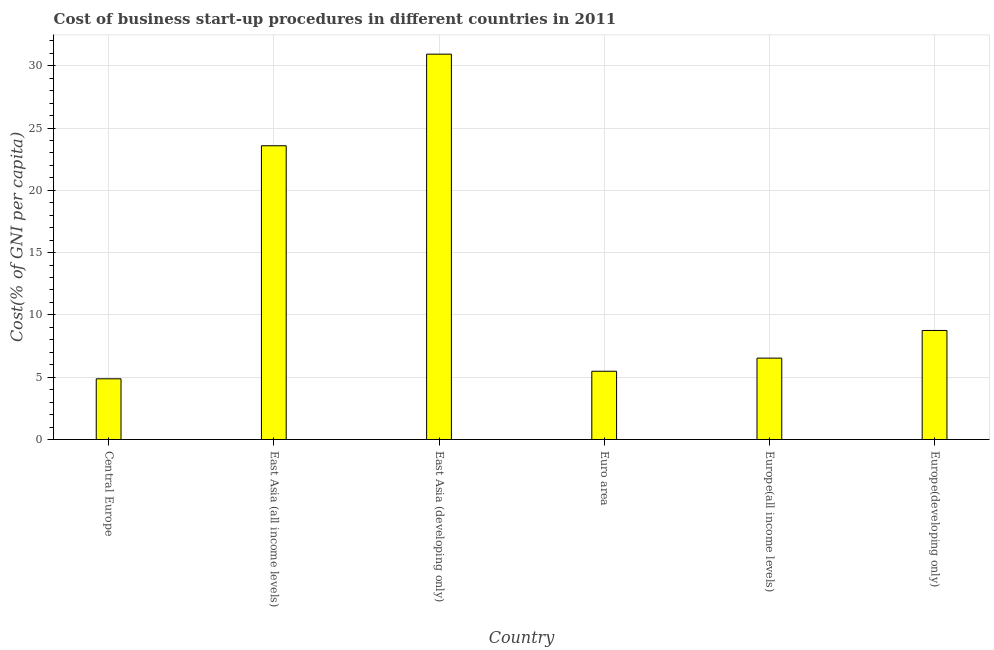Does the graph contain grids?
Keep it short and to the point. Yes. What is the title of the graph?
Offer a terse response. Cost of business start-up procedures in different countries in 2011. What is the label or title of the Y-axis?
Your answer should be compact. Cost(% of GNI per capita). What is the cost of business startup procedures in Central Europe?
Provide a succinct answer. 4.87. Across all countries, what is the maximum cost of business startup procedures?
Offer a very short reply. 30.93. Across all countries, what is the minimum cost of business startup procedures?
Your answer should be very brief. 4.87. In which country was the cost of business startup procedures maximum?
Your answer should be compact. East Asia (developing only). In which country was the cost of business startup procedures minimum?
Your response must be concise. Central Europe. What is the sum of the cost of business startup procedures?
Offer a very short reply. 80.14. What is the difference between the cost of business startup procedures in East Asia (developing only) and Europe(all income levels)?
Your response must be concise. 24.4. What is the average cost of business startup procedures per country?
Keep it short and to the point. 13.36. What is the median cost of business startup procedures?
Your answer should be compact. 7.64. What is the ratio of the cost of business startup procedures in Central Europe to that in East Asia (all income levels)?
Your answer should be very brief. 0.21. What is the difference between the highest and the second highest cost of business startup procedures?
Provide a succinct answer. 7.35. Is the sum of the cost of business startup procedures in Euro area and Europe(all income levels) greater than the maximum cost of business startup procedures across all countries?
Your answer should be very brief. No. What is the difference between the highest and the lowest cost of business startup procedures?
Keep it short and to the point. 26.06. In how many countries, is the cost of business startup procedures greater than the average cost of business startup procedures taken over all countries?
Provide a short and direct response. 2. What is the difference between two consecutive major ticks on the Y-axis?
Offer a terse response. 5. What is the Cost(% of GNI per capita) in Central Europe?
Provide a short and direct response. 4.87. What is the Cost(% of GNI per capita) in East Asia (all income levels)?
Ensure brevity in your answer.  23.58. What is the Cost(% of GNI per capita) in East Asia (developing only)?
Keep it short and to the point. 30.93. What is the Cost(% of GNI per capita) in Euro area?
Offer a terse response. 5.48. What is the Cost(% of GNI per capita) of Europe(all income levels)?
Your response must be concise. 6.53. What is the Cost(% of GNI per capita) in Europe(developing only)?
Your answer should be very brief. 8.75. What is the difference between the Cost(% of GNI per capita) in Central Europe and East Asia (all income levels)?
Provide a succinct answer. -18.7. What is the difference between the Cost(% of GNI per capita) in Central Europe and East Asia (developing only)?
Your response must be concise. -26.06. What is the difference between the Cost(% of GNI per capita) in Central Europe and Euro area?
Your answer should be very brief. -0.61. What is the difference between the Cost(% of GNI per capita) in Central Europe and Europe(all income levels)?
Offer a very short reply. -1.66. What is the difference between the Cost(% of GNI per capita) in Central Europe and Europe(developing only)?
Your answer should be very brief. -3.88. What is the difference between the Cost(% of GNI per capita) in East Asia (all income levels) and East Asia (developing only)?
Your answer should be compact. -7.35. What is the difference between the Cost(% of GNI per capita) in East Asia (all income levels) and Euro area?
Give a very brief answer. 18.1. What is the difference between the Cost(% of GNI per capita) in East Asia (all income levels) and Europe(all income levels)?
Your answer should be compact. 17.04. What is the difference between the Cost(% of GNI per capita) in East Asia (all income levels) and Europe(developing only)?
Provide a short and direct response. 14.82. What is the difference between the Cost(% of GNI per capita) in East Asia (developing only) and Euro area?
Your response must be concise. 25.45. What is the difference between the Cost(% of GNI per capita) in East Asia (developing only) and Europe(all income levels)?
Provide a short and direct response. 24.4. What is the difference between the Cost(% of GNI per capita) in East Asia (developing only) and Europe(developing only)?
Your answer should be very brief. 22.18. What is the difference between the Cost(% of GNI per capita) in Euro area and Europe(all income levels)?
Provide a short and direct response. -1.05. What is the difference between the Cost(% of GNI per capita) in Euro area and Europe(developing only)?
Offer a very short reply. -3.27. What is the difference between the Cost(% of GNI per capita) in Europe(all income levels) and Europe(developing only)?
Provide a short and direct response. -2.22. What is the ratio of the Cost(% of GNI per capita) in Central Europe to that in East Asia (all income levels)?
Offer a very short reply. 0.21. What is the ratio of the Cost(% of GNI per capita) in Central Europe to that in East Asia (developing only)?
Make the answer very short. 0.16. What is the ratio of the Cost(% of GNI per capita) in Central Europe to that in Euro area?
Keep it short and to the point. 0.89. What is the ratio of the Cost(% of GNI per capita) in Central Europe to that in Europe(all income levels)?
Your answer should be very brief. 0.75. What is the ratio of the Cost(% of GNI per capita) in Central Europe to that in Europe(developing only)?
Offer a terse response. 0.56. What is the ratio of the Cost(% of GNI per capita) in East Asia (all income levels) to that in East Asia (developing only)?
Provide a succinct answer. 0.76. What is the ratio of the Cost(% of GNI per capita) in East Asia (all income levels) to that in Euro area?
Ensure brevity in your answer.  4.3. What is the ratio of the Cost(% of GNI per capita) in East Asia (all income levels) to that in Europe(all income levels)?
Provide a succinct answer. 3.61. What is the ratio of the Cost(% of GNI per capita) in East Asia (all income levels) to that in Europe(developing only)?
Ensure brevity in your answer.  2.69. What is the ratio of the Cost(% of GNI per capita) in East Asia (developing only) to that in Euro area?
Provide a succinct answer. 5.64. What is the ratio of the Cost(% of GNI per capita) in East Asia (developing only) to that in Europe(all income levels)?
Your answer should be compact. 4.74. What is the ratio of the Cost(% of GNI per capita) in East Asia (developing only) to that in Europe(developing only)?
Keep it short and to the point. 3.53. What is the ratio of the Cost(% of GNI per capita) in Euro area to that in Europe(all income levels)?
Your response must be concise. 0.84. What is the ratio of the Cost(% of GNI per capita) in Euro area to that in Europe(developing only)?
Make the answer very short. 0.63. What is the ratio of the Cost(% of GNI per capita) in Europe(all income levels) to that in Europe(developing only)?
Your answer should be compact. 0.75. 